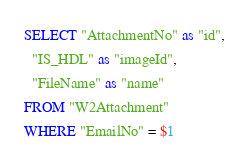<code> <loc_0><loc_0><loc_500><loc_500><_SQL_>SELECT "AttachmentNo" as "id",
  "IS_HDL" as "imageId",
  "FileName" as "name"
FROM "W2Attachment"
WHERE "EmailNo" = $1
</code> 